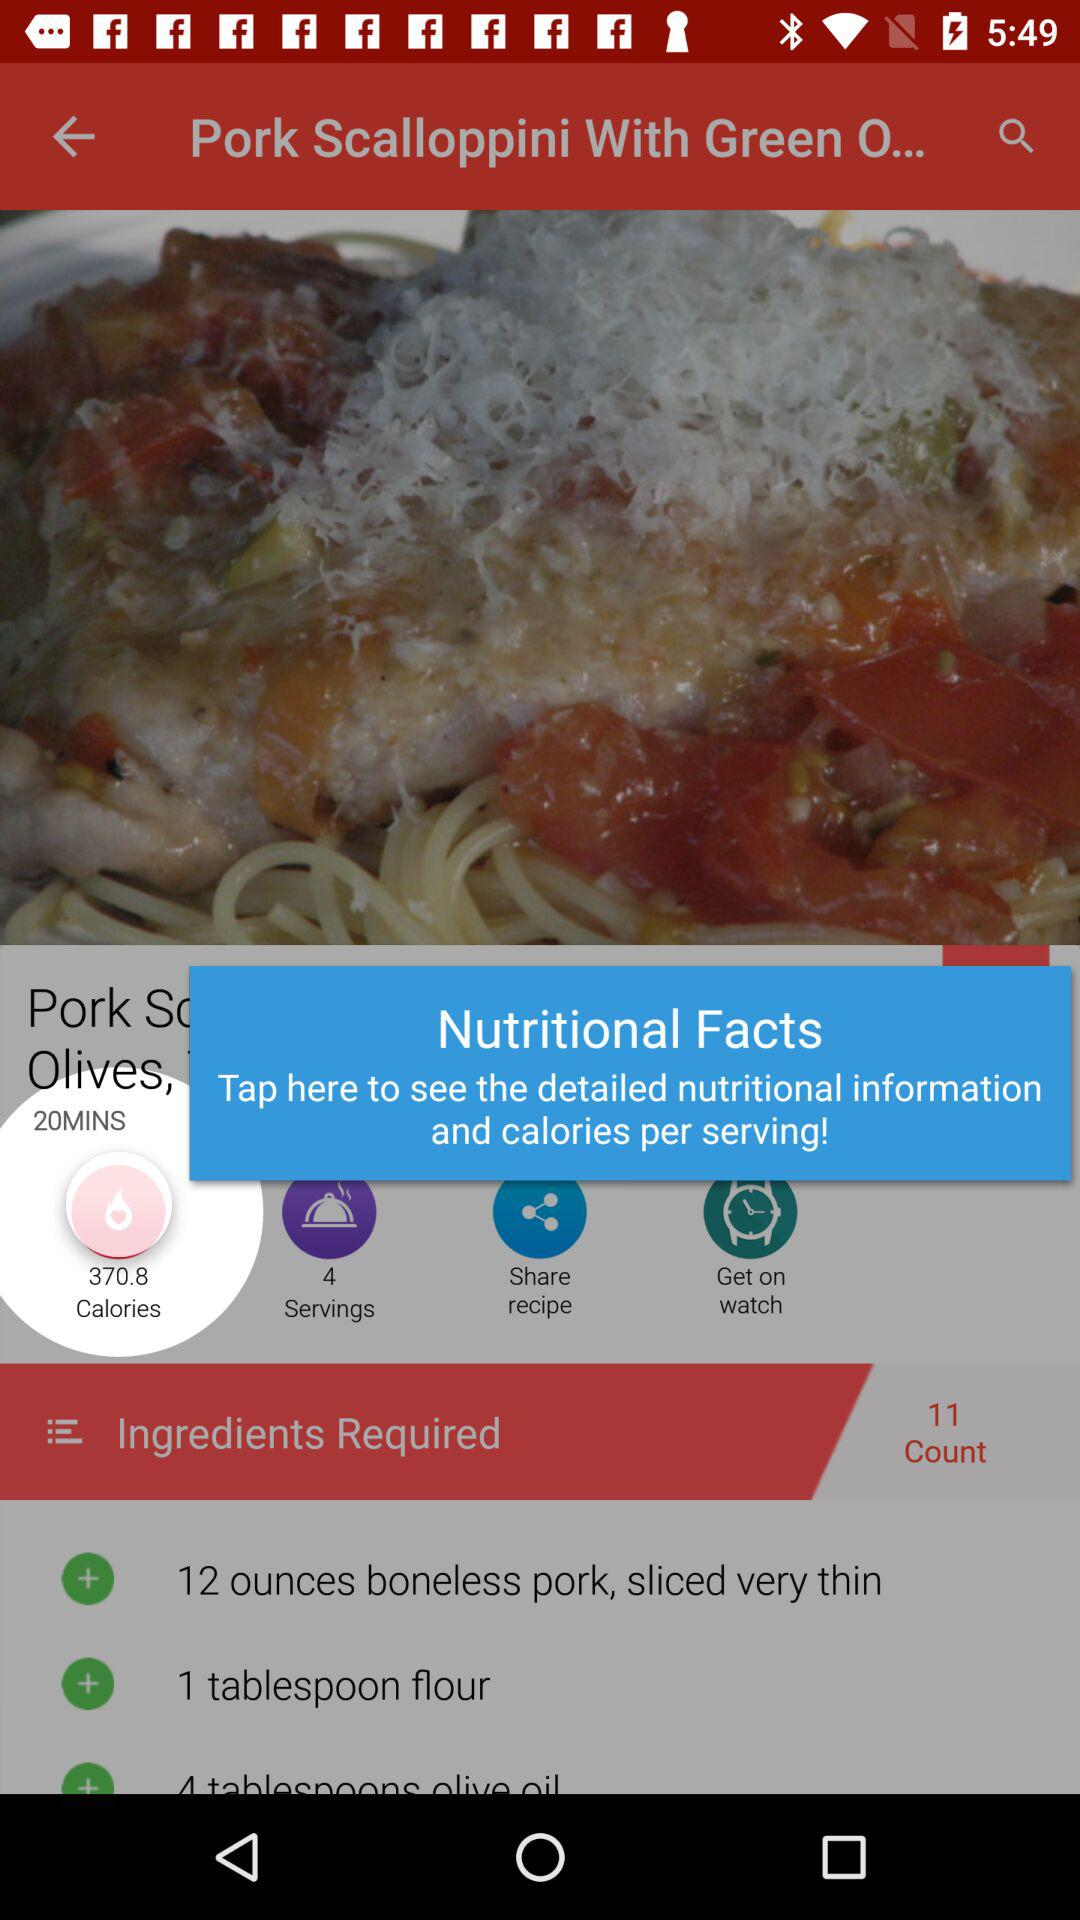How many servings does the recipe make?
Answer the question using a single word or phrase. 4 